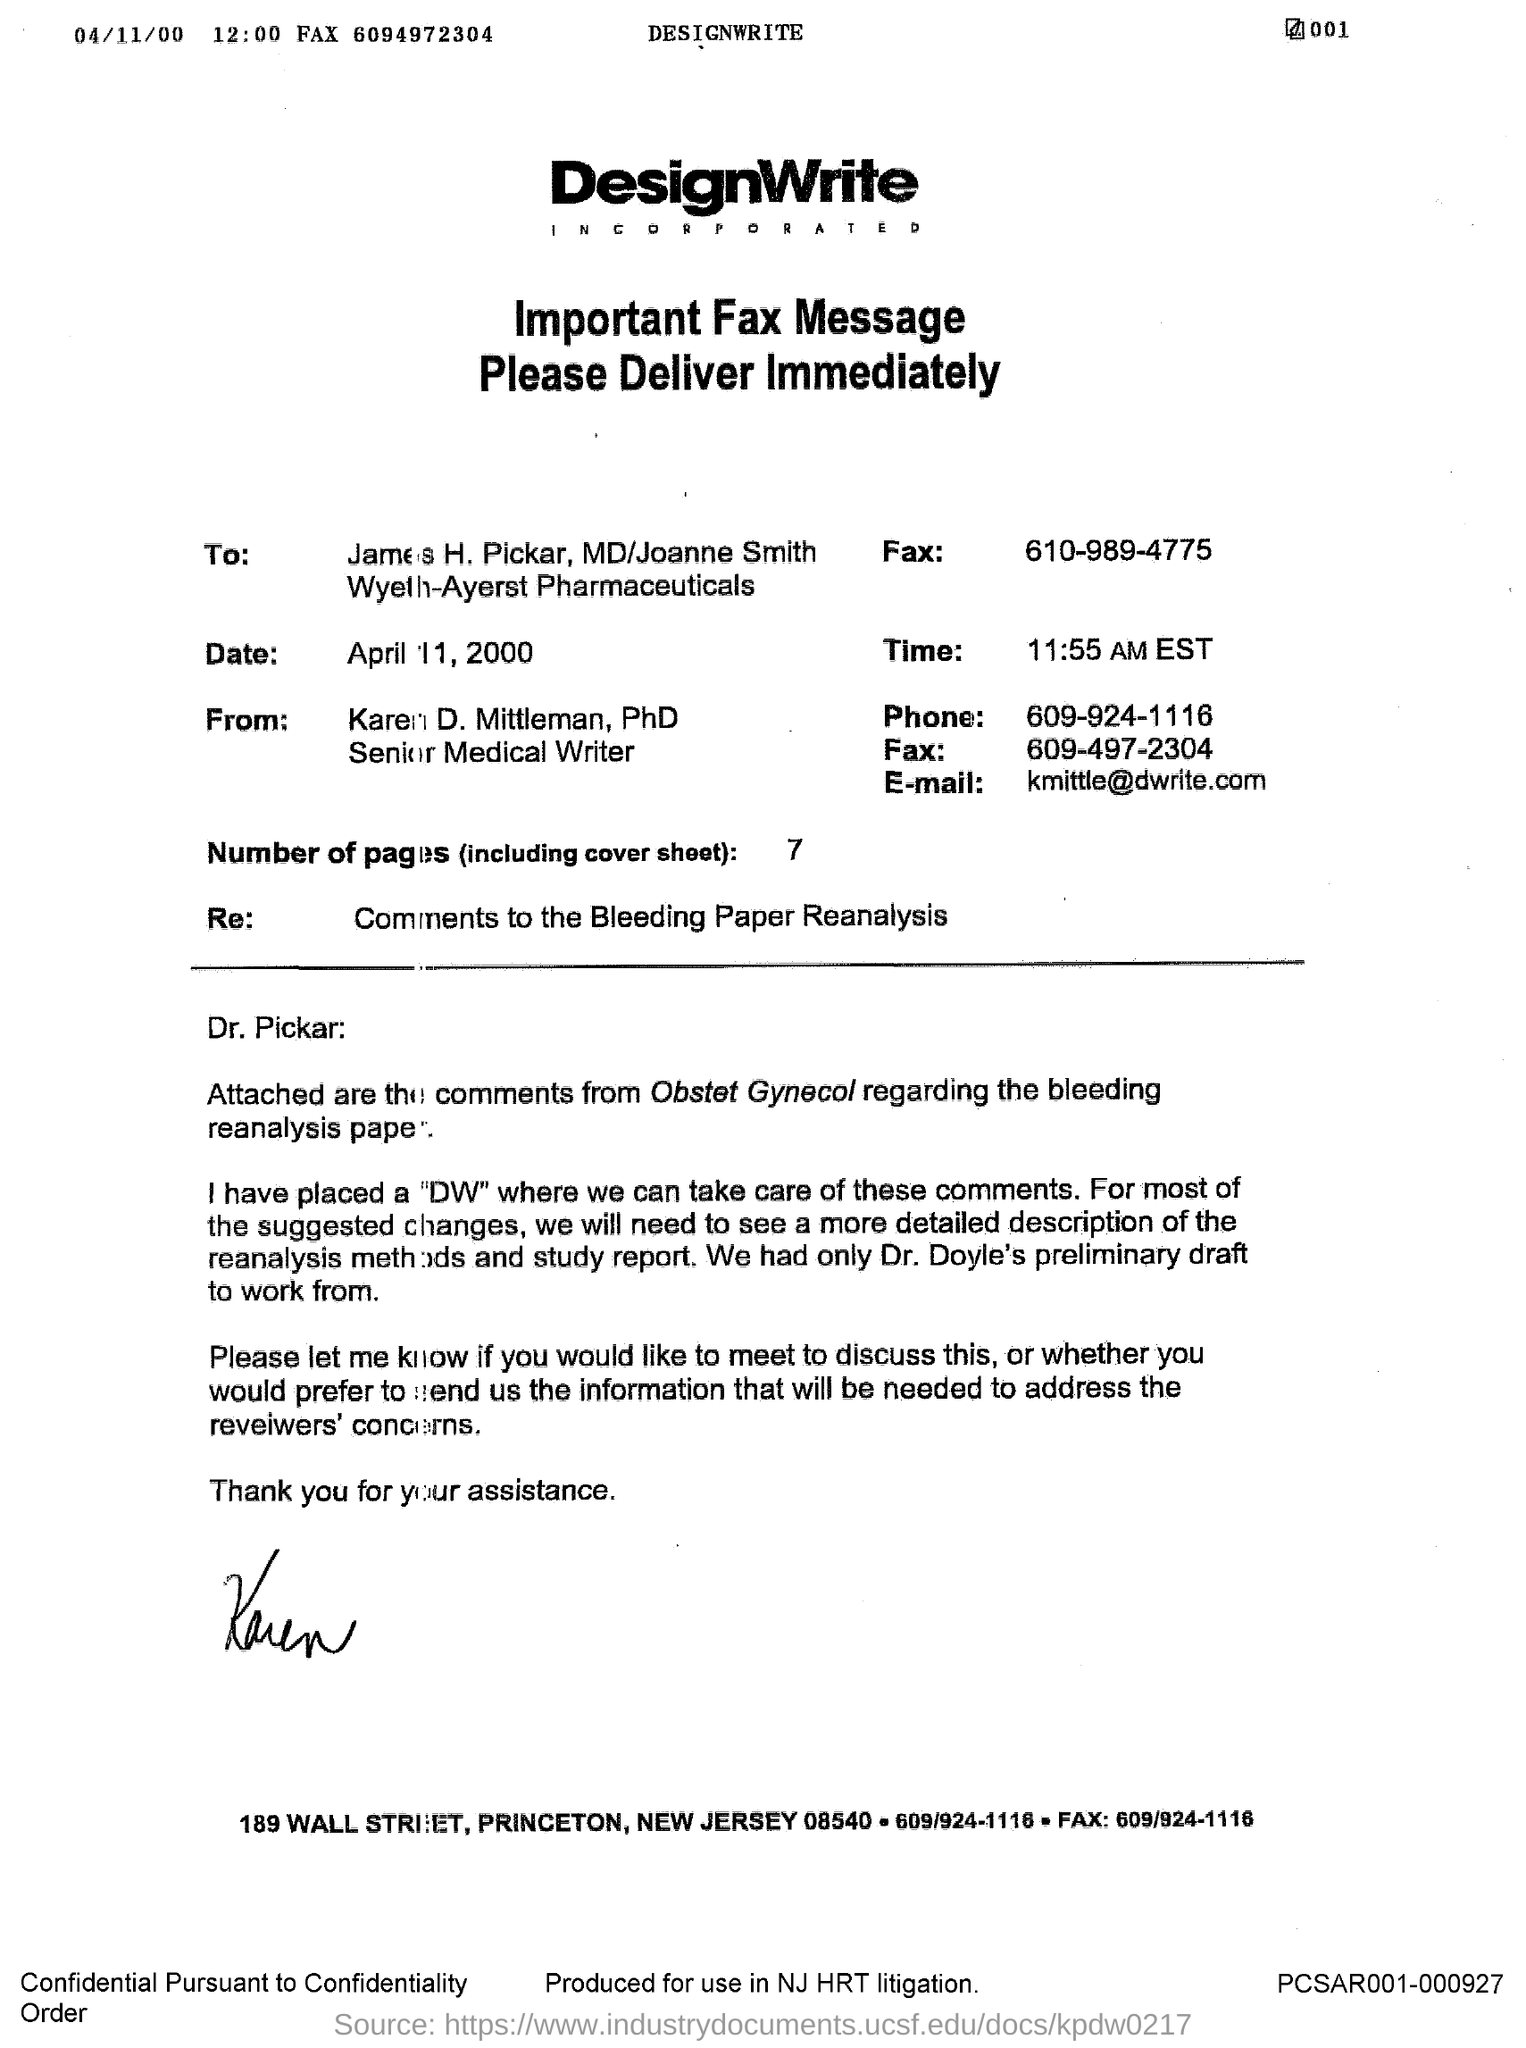Highlight a few significant elements in this photo. The time mentioned is 11:55 AM EST. The draft of Dr. Doyle is available. 